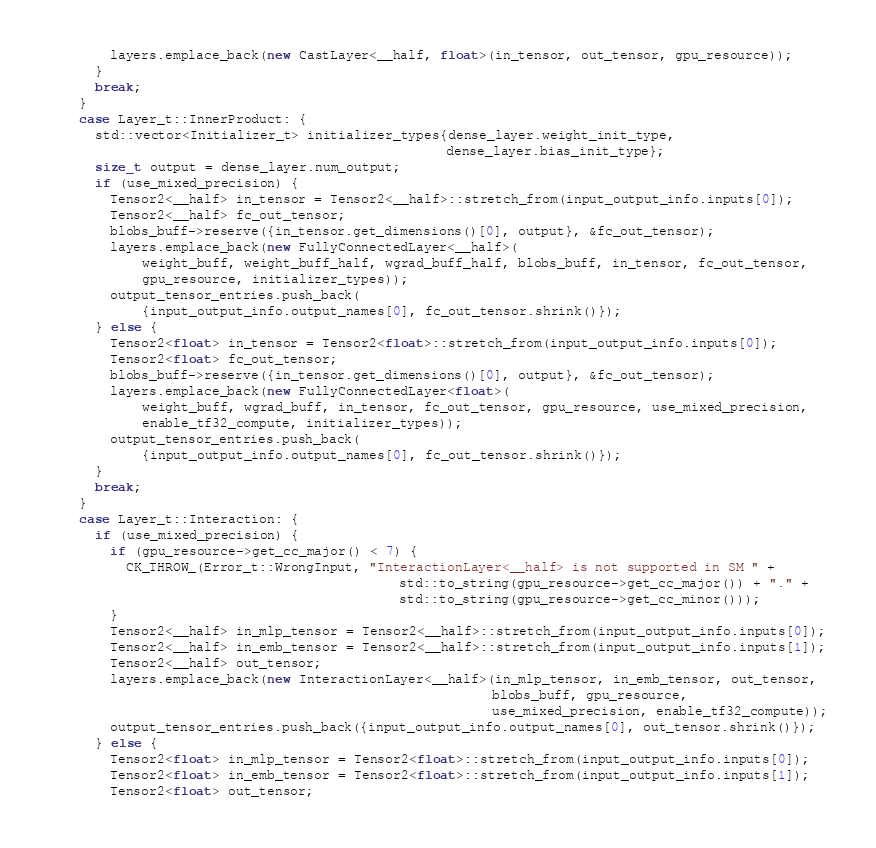Convert code to text. <code><loc_0><loc_0><loc_500><loc_500><_C++_>        layers.emplace_back(new CastLayer<__half, float>(in_tensor, out_tensor, gpu_resource));
      }
      break;
    }
    case Layer_t::InnerProduct: {
      std::vector<Initializer_t> initializer_types{dense_layer.weight_init_type,
                                                   dense_layer.bias_init_type};
      size_t output = dense_layer.num_output;
      if (use_mixed_precision) {
        Tensor2<__half> in_tensor = Tensor2<__half>::stretch_from(input_output_info.inputs[0]);
        Tensor2<__half> fc_out_tensor;
        blobs_buff->reserve({in_tensor.get_dimensions()[0], output}, &fc_out_tensor);
        layers.emplace_back(new FullyConnectedLayer<__half>(
            weight_buff, weight_buff_half, wgrad_buff_half, blobs_buff, in_tensor, fc_out_tensor,
            gpu_resource, initializer_types));
        output_tensor_entries.push_back(
            {input_output_info.output_names[0], fc_out_tensor.shrink()});
      } else {
        Tensor2<float> in_tensor = Tensor2<float>::stretch_from(input_output_info.inputs[0]);
        Tensor2<float> fc_out_tensor;
        blobs_buff->reserve({in_tensor.get_dimensions()[0], output}, &fc_out_tensor);
        layers.emplace_back(new FullyConnectedLayer<float>(
            weight_buff, wgrad_buff, in_tensor, fc_out_tensor, gpu_resource, use_mixed_precision,
            enable_tf32_compute, initializer_types));
        output_tensor_entries.push_back(
            {input_output_info.output_names[0], fc_out_tensor.shrink()});
      }
      break;
    }
    case Layer_t::Interaction: {
      if (use_mixed_precision) {
        if (gpu_resource->get_cc_major() < 7) {
          CK_THROW_(Error_t::WrongInput, "InteractionLayer<__half> is not supported in SM " +
                                             std::to_string(gpu_resource->get_cc_major()) + "." +
                                             std::to_string(gpu_resource->get_cc_minor()));
        }
        Tensor2<__half> in_mlp_tensor = Tensor2<__half>::stretch_from(input_output_info.inputs[0]);
        Tensor2<__half> in_emb_tensor = Tensor2<__half>::stretch_from(input_output_info.inputs[1]);
        Tensor2<__half> out_tensor;
        layers.emplace_back(new InteractionLayer<__half>(in_mlp_tensor, in_emb_tensor, out_tensor,
                                                         blobs_buff, gpu_resource,
                                                         use_mixed_precision, enable_tf32_compute));
        output_tensor_entries.push_back({input_output_info.output_names[0], out_tensor.shrink()});
      } else {
        Tensor2<float> in_mlp_tensor = Tensor2<float>::stretch_from(input_output_info.inputs[0]);
        Tensor2<float> in_emb_tensor = Tensor2<float>::stretch_from(input_output_info.inputs[1]);
        Tensor2<float> out_tensor;</code> 